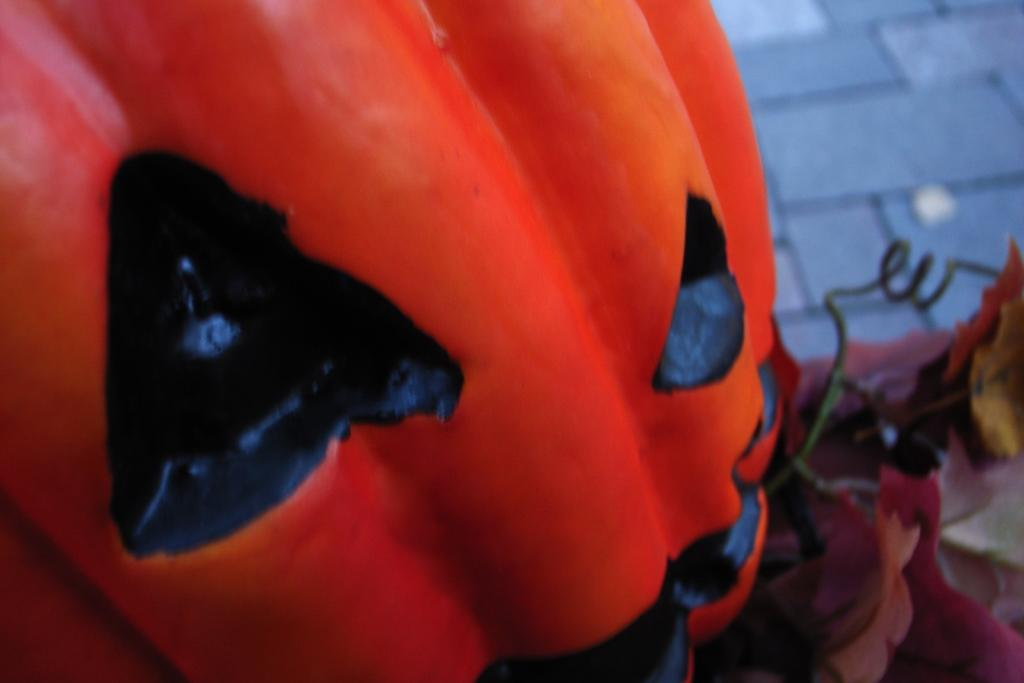What is the main object in the front of the image? There is a pumpkin in the front of the image. What type of surface can be seen in the background of the image? There are tiles visible in the background of the image. How would you describe the clarity of the background in the image? The background appears blurry. How many laborers can be seen working on the boats in the background of the image? There are no laborers or boats present in the image; it features a pumpkin in the front and a blurry background with tiles. 